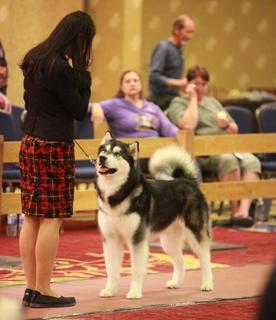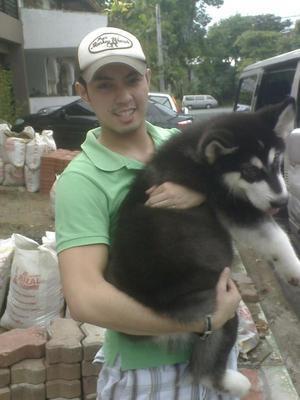The first image is the image on the left, the second image is the image on the right. Examine the images to the left and right. Is the description "Three people are sitting and posing for a portrait with a Malamute." accurate? Answer yes or no. No. 